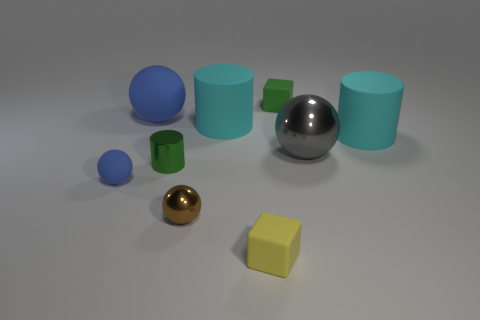Add 1 metal balls. How many objects exist? 10 Subtract all cylinders. How many objects are left? 6 Add 6 cyan cylinders. How many cyan cylinders are left? 8 Add 8 matte cylinders. How many matte cylinders exist? 10 Subtract 0 yellow balls. How many objects are left? 9 Subtract all large gray spheres. Subtract all tiny brown cubes. How many objects are left? 8 